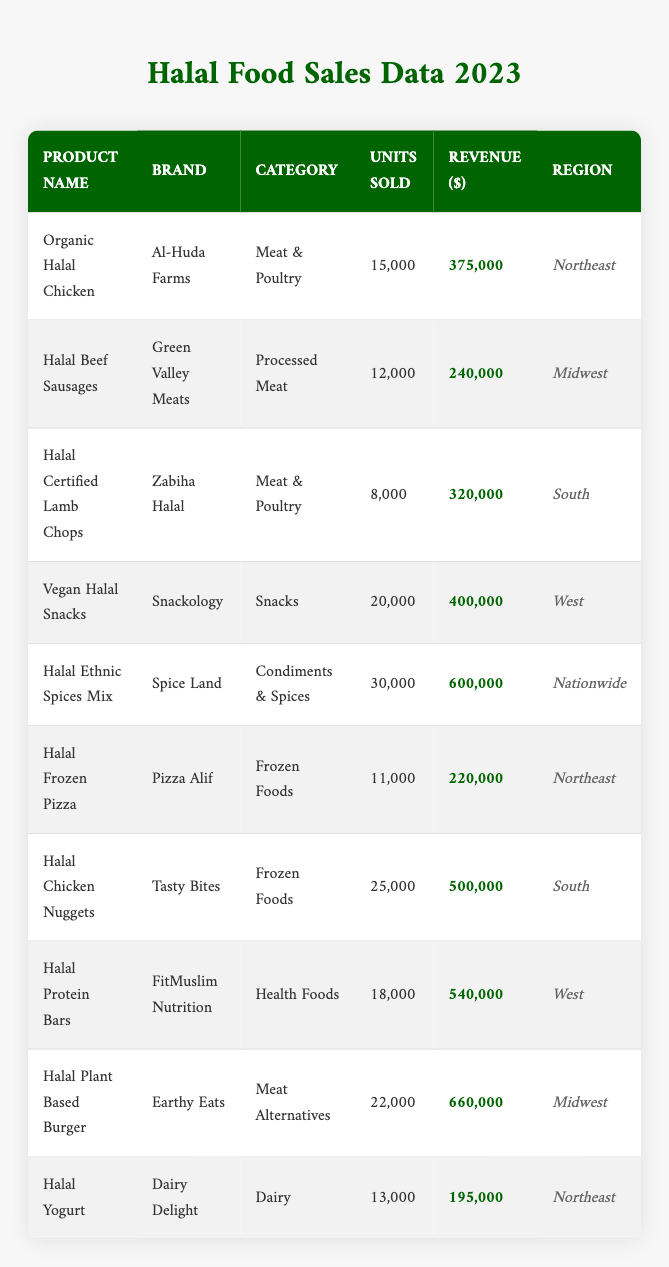What is the total revenue generated from "Halal Chicken Nuggets"? The revenue for "Halal Chicken Nuggets" is listed under the revenue column, which is $500,000.
Answer: $500,000 Which product sold the most units? The product with the highest units sold is "Halal Ethnic Spices Mix" with 30,000 units.
Answer: "Halal Ethnic Spices Mix" What is the average revenue of all products listed in the table? To calculate the average revenue, sum all revenues: (375000 + 240000 + 320000 + 400000 + 600000 + 220000 + 500000 + 540000 + 660000 + 195000) = 3060000. There are 10 products, so the average revenue is 3060000/10 = 306000.
Answer: $306,000 Did "Earthy Eats" sell more than "Green Valley Meats"? "Earthy Eats" sold 22,000 units while "Green Valley Meats" sold 12,000 units, so yes, Earthy Eats sold more.
Answer: Yes Which region generated the highest total revenue? To find the highest total revenue region, sum the revenues for each region: Northeast ($375,000 + $220,000 + $195,000) = $790,000, Midwest ($240,000 + $660,000) = $900,000, South ($320,000 + $500,000) = $820,000, and West ($400,000 + $540,000) = $940,000. The West region generated the highest revenue with $940,000.
Answer: West How many more units did "Vegan Halal Snacks" sell compared to "Halal Frozen Pizza"? "Vegan Halal Snacks" sold 20,000 units and "Halal Frozen Pizza" sold 11,000 units. The difference is 20,000 - 11,000 = 9,000 units.
Answer: 9,000 units Is there any product from the "Dairy" category? Yes, there is a product listed under the "Dairy" category, which is "Halal Yogurt."
Answer: Yes What is the total number of units sold for "Processed Meat"? For "Processed Meat," the units sold are from "Halal Beef Sausages" which sold 12,000 units only. There is no other product in this category. Thus, the total is 12,000.
Answer: 12,000 units Which category has the highest revenue, and what is that revenue? Compare revenues for all categories: "Meat & Poultry" ($695,000), "Processed Meat" ($240,000), "Snacks" ($400,000), "Condiments & Spices" ($600,000), "Frozen Foods" ($720,000), "Health Foods" ($540,000), and "Dairy" ($195,000). The highest revenue is from "Frozen Foods" at $720,000.
Answer: Frozen Foods, $720,000 How many units sold for "Halal Certified Lamb Chops" were less than "Halal Plant Based Burger"? "Halal Certified Lamb Chops" sold 8,000 units, while "Halal Plant Based Burger" sold 22,000 units. The difference is 22,000 - 8,000 = 14,000 units less for Lamb Chops.
Answer: 14,000 units Which brand has the second highest revenue and what is that revenue? The revenues sorted are: "Earthy Eats" ($660,000), "Halal Chicken Nuggets" ($500,000), and others. The second highest revenue is from "Halal Chicken Nuggets" with $500,000.
Answer: Halal Chicken Nuggets, $500,000 